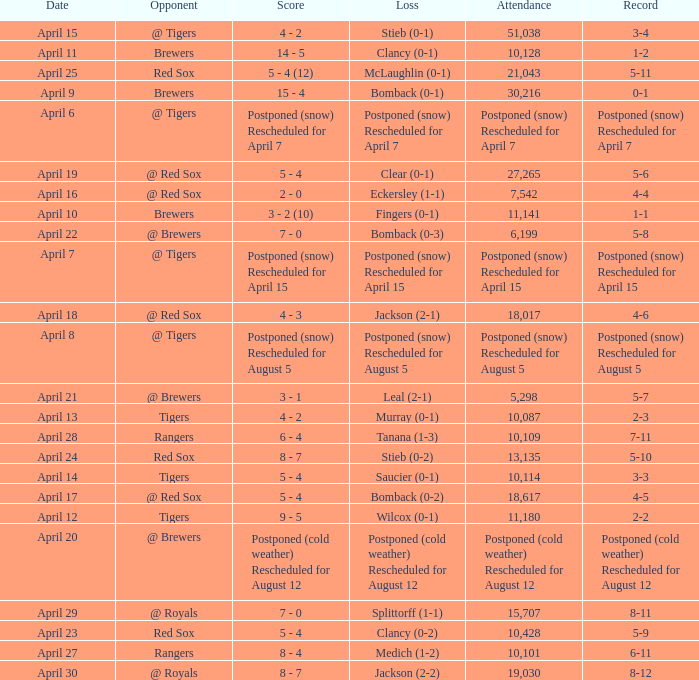Which record is dated April 8? Postponed (snow) Rescheduled for August 5. 